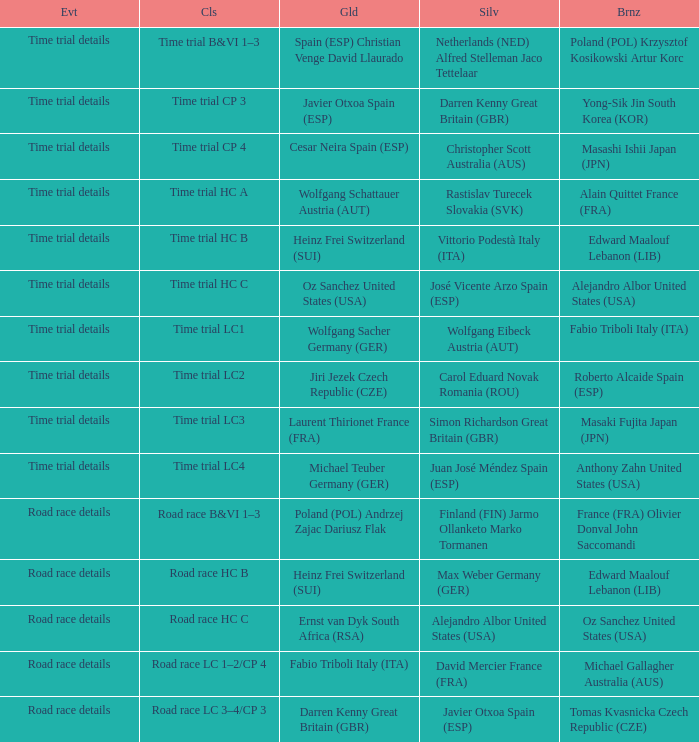Who received gold when the event is time trial details and silver is simon richardson great britain (gbr)? Laurent Thirionet France (FRA). 